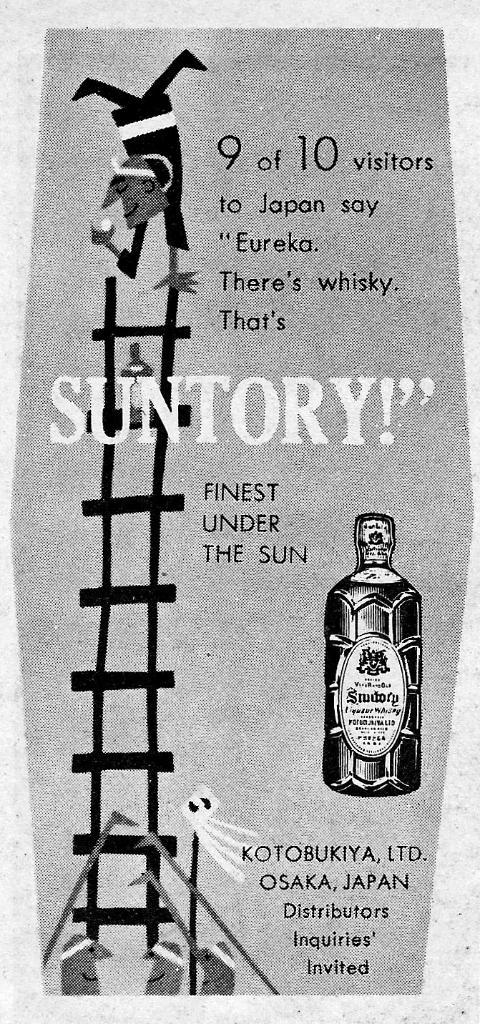<image>
Summarize the visual content of the image. a bottle that is a cartoon that is below text that says Suntory 